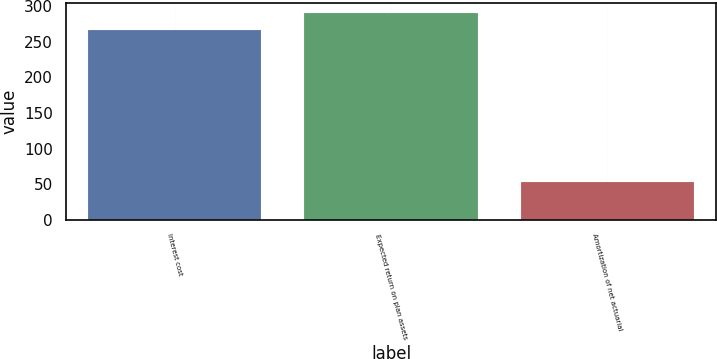Convert chart to OTSL. <chart><loc_0><loc_0><loc_500><loc_500><bar_chart><fcel>Interest cost<fcel>Expected return on plan assets<fcel>Amortization of net actuarial<nl><fcel>267<fcel>290.4<fcel>53<nl></chart> 